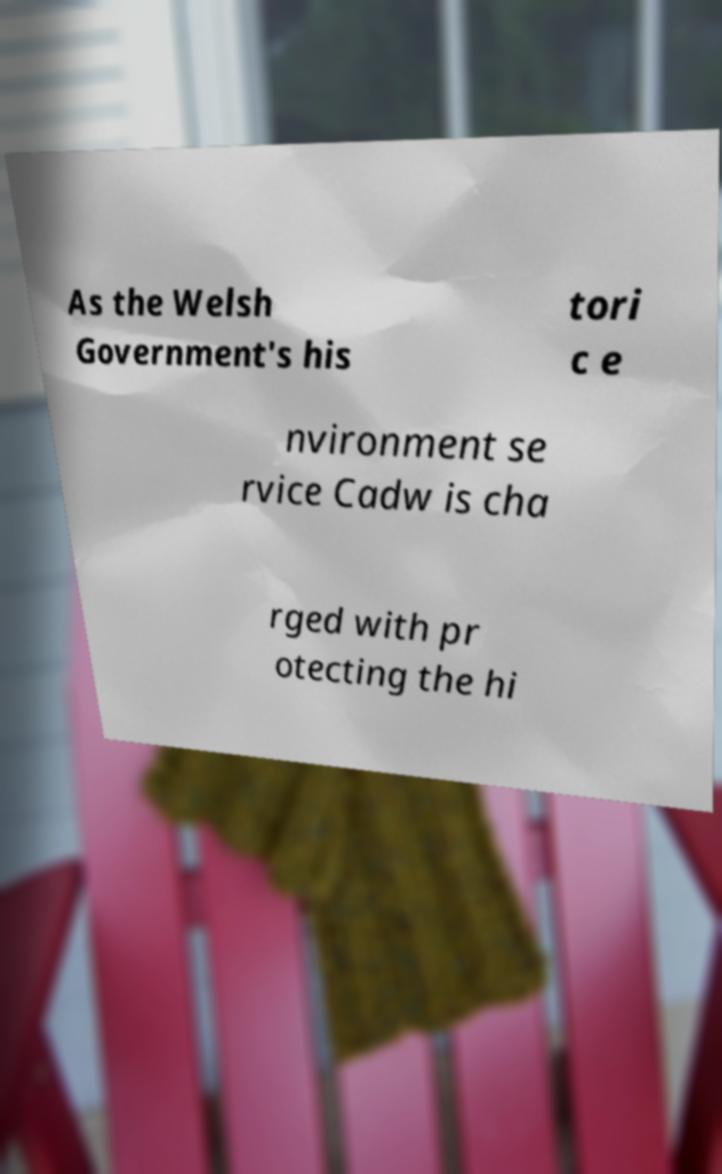Could you assist in decoding the text presented in this image and type it out clearly? As the Welsh Government's his tori c e nvironment se rvice Cadw is cha rged with pr otecting the hi 